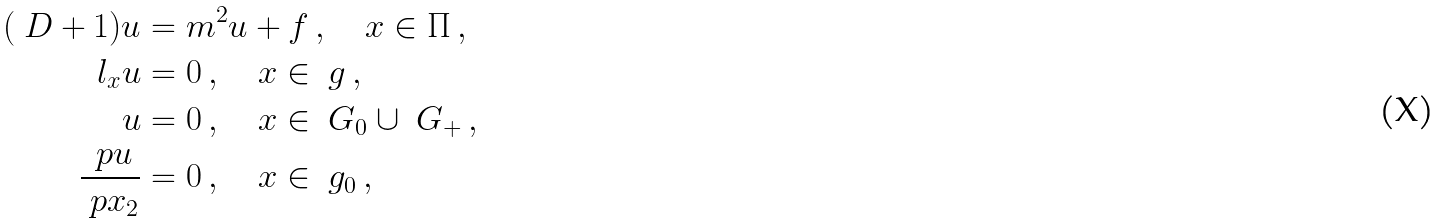Convert formula to latex. <formula><loc_0><loc_0><loc_500><loc_500>( \ D + 1 ) u & = m ^ { 2 } u + f \, , \quad x \in \Pi \, , \\ l _ { x } u & = 0 \, , \quad x \in \ g \, , \\ u & = 0 \, , \quad x \in \ G _ { 0 } \cup \ G _ { + } \, , \\ \frac { \ p u } { \ p x _ { 2 } } & = 0 \, , \quad x \in \ g _ { 0 } \, ,</formula> 